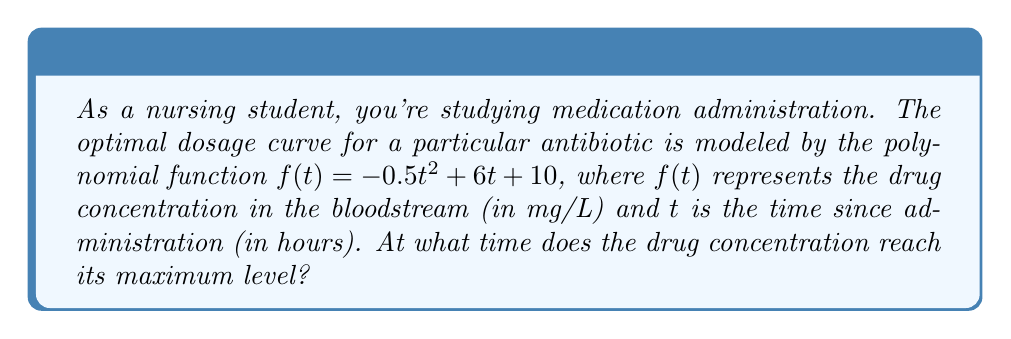Provide a solution to this math problem. Let's approach this step-by-step:

1) The function $f(t) = -0.5t^2 + 6t + 10$ is a quadratic function, which forms a parabola when graphed.

2) For a quadratic function in the form $f(t) = at^2 + bt + c$, the vertex of the parabola occurs at $t = -\frac{b}{2a}$.

3) In our case, $a = -0.5$ and $b = 6$. Let's substitute these values:

   $t = -\frac{6}{2(-0.5)} = -\frac{6}{-1} = 6$

4) To confirm this is a maximum (not a minimum), we can check the sign of $a$:
   - If $a < 0$ (which it is in this case), the parabola opens downward and the vertex is a maximum.
   - If $a > 0$, the parabola would open upward and the vertex would be a minimum.

5) Since $a = -0.5 < 0$, the vertex represents the maximum point of the function.

Therefore, the drug concentration reaches its maximum level at $t = 6$ hours after administration.
Answer: 6 hours 